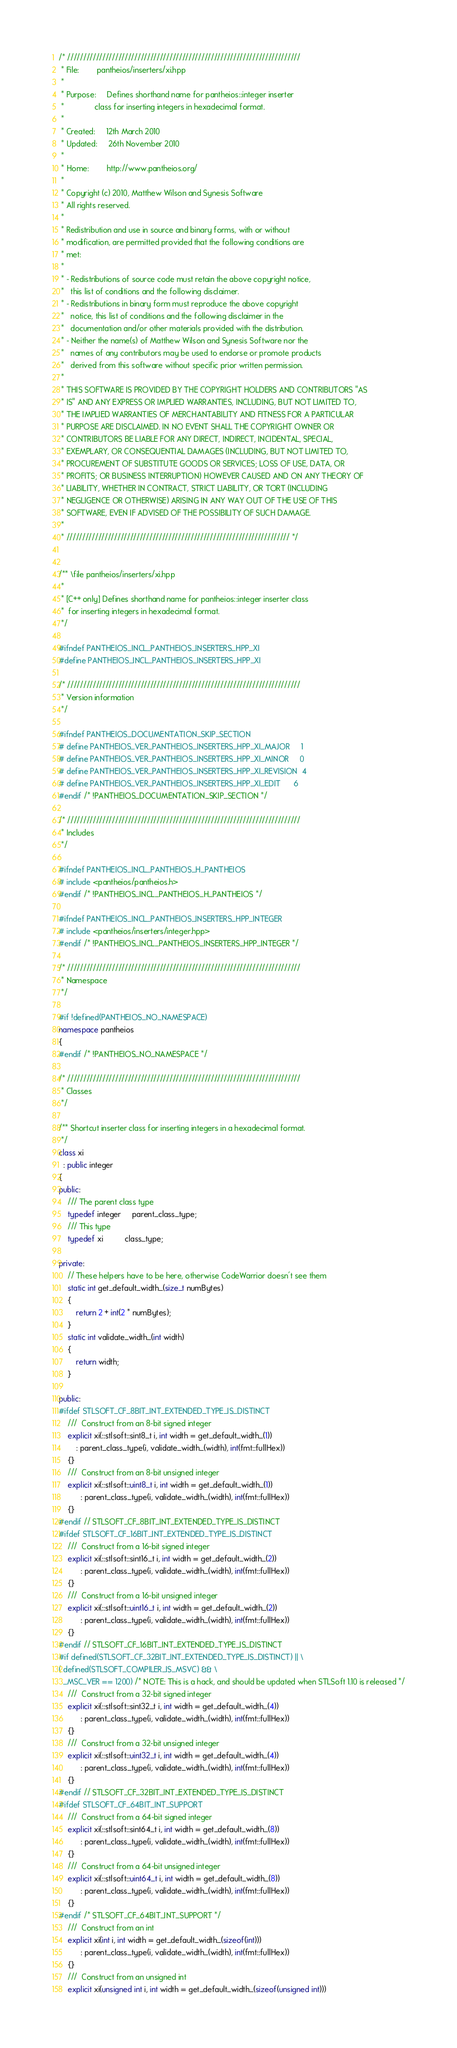<code> <loc_0><loc_0><loc_500><loc_500><_C++_>/* /////////////////////////////////////////////////////////////////////////
 * File:        pantheios/inserters/xi.hpp
 *
 * Purpose:     Defines shorthand name for pantheios::integer inserter
 *              class for inserting integers in hexadecimal format.
 *
 * Created:     12th March 2010
 * Updated:     26th November 2010
 *
 * Home:        http://www.pantheios.org/
 *
 * Copyright (c) 2010, Matthew Wilson and Synesis Software
 * All rights reserved.
 *
 * Redistribution and use in source and binary forms, with or without
 * modification, are permitted provided that the following conditions are
 * met:
 *
 * - Redistributions of source code must retain the above copyright notice,
 *   this list of conditions and the following disclaimer.
 * - Redistributions in binary form must reproduce the above copyright
 *   notice, this list of conditions and the following disclaimer in the
 *   documentation and/or other materials provided with the distribution.
 * - Neither the name(s) of Matthew Wilson and Synesis Software nor the
 *   names of any contributors may be used to endorse or promote products
 *   derived from this software without specific prior written permission.
 *
 * THIS SOFTWARE IS PROVIDED BY THE COPYRIGHT HOLDERS AND CONTRIBUTORS "AS
 * IS" AND ANY EXPRESS OR IMPLIED WARRANTIES, INCLUDING, BUT NOT LIMITED TO,
 * THE IMPLIED WARRANTIES OF MERCHANTABILITY AND FITNESS FOR A PARTICULAR
 * PURPOSE ARE DISCLAIMED. IN NO EVENT SHALL THE COPYRIGHT OWNER OR
 * CONTRIBUTORS BE LIABLE FOR ANY DIRECT, INDIRECT, INCIDENTAL, SPECIAL,
 * EXEMPLARY, OR CONSEQUENTIAL DAMAGES (INCLUDING, BUT NOT LIMITED TO,
 * PROCUREMENT OF SUBSTITUTE GOODS OR SERVICES; LOSS OF USE, DATA, OR
 * PROFITS; OR BUSINESS INTERRUPTION) HOWEVER CAUSED AND ON ANY THEORY OF
 * LIABILITY, WHETHER IN CONTRACT, STRICT LIABILITY, OR TORT (INCLUDING
 * NEGLIGENCE OR OTHERWISE) ARISING IN ANY WAY OUT OF THE USE OF THIS
 * SOFTWARE, EVEN IF ADVISED OF THE POSSIBILITY OF SUCH DAMAGE.
 *
 * ////////////////////////////////////////////////////////////////////// */


/** \file pantheios/inserters/xi.hpp
 *
 * [C++ only] Defines shorthand name for pantheios::integer inserter class
 *  for inserting integers in hexadecimal format.
 */

#ifndef PANTHEIOS_INCL_PANTHEIOS_INSERTERS_HPP_XI
#define PANTHEIOS_INCL_PANTHEIOS_INSERTERS_HPP_XI

/* /////////////////////////////////////////////////////////////////////////
 * Version information
 */

#ifndef PANTHEIOS_DOCUMENTATION_SKIP_SECTION
# define PANTHEIOS_VER_PANTHEIOS_INSERTERS_HPP_XI_MAJOR     1
# define PANTHEIOS_VER_PANTHEIOS_INSERTERS_HPP_XI_MINOR     0
# define PANTHEIOS_VER_PANTHEIOS_INSERTERS_HPP_XI_REVISION  4
# define PANTHEIOS_VER_PANTHEIOS_INSERTERS_HPP_XI_EDIT      6
#endif /* !PANTHEIOS_DOCUMENTATION_SKIP_SECTION */

/* /////////////////////////////////////////////////////////////////////////
 * Includes
 */

#ifndef PANTHEIOS_INCL_PANTHEIOS_H_PANTHEIOS
# include <pantheios/pantheios.h>
#endif /* !PANTHEIOS_INCL_PANTHEIOS_H_PANTHEIOS */

#ifndef PANTHEIOS_INCL_PANTHEIOS_INSERTERS_HPP_INTEGER
# include <pantheios/inserters/integer.hpp>
#endif /* !PANTHEIOS_INCL_PANTHEIOS_INSERTERS_HPP_INTEGER */

/* /////////////////////////////////////////////////////////////////////////
 * Namespace
 */

#if !defined(PANTHEIOS_NO_NAMESPACE)
namespace pantheios
{
#endif /* !PANTHEIOS_NO_NAMESPACE */

/* /////////////////////////////////////////////////////////////////////////
 * Classes
 */

/** Shortcut inserter class for inserting integers in a hexadecimal format.
 */
class xi
  : public integer
{
public:
    /// The parent class type
    typedef integer     parent_class_type;
    /// This type
    typedef xi          class_type;

private:
    // These helpers have to be here, otherwise CodeWarrior doesn't see them
    static int get_default_width_(size_t numBytes)
    {
        return 2 + int(2 * numBytes);
    }
    static int validate_width_(int width)
    {
        return width;
    }

public:
#ifdef STLSOFT_CF_8BIT_INT_EXTENDED_TYPE_IS_DISTINCT
    ///  Construct from an 8-bit signed integer
    explicit xi(::stlsoft::sint8_t i, int width = get_default_width_(1))
        : parent_class_type(i, validate_width_(width), int(fmt::fullHex))
    {}
    ///  Construct from an 8-bit unsigned integer
    explicit xi(::stlsoft::uint8_t i, int width = get_default_width_(1))
          : parent_class_type(i, validate_width_(width), int(fmt::fullHex))
    {}
#endif // STLSOFT_CF_8BIT_INT_EXTENDED_TYPE_IS_DISTINCT
#ifdef STLSOFT_CF_16BIT_INT_EXTENDED_TYPE_IS_DISTINCT
    ///  Construct from a 16-bit signed integer
    explicit xi(::stlsoft::sint16_t i, int width = get_default_width_(2))
          : parent_class_type(i, validate_width_(width), int(fmt::fullHex))
    {}
    ///  Construct from a 16-bit unsigned integer
    explicit xi(::stlsoft::uint16_t i, int width = get_default_width_(2))
          : parent_class_type(i, validate_width_(width), int(fmt::fullHex))
    {}
#endif // STLSOFT_CF_16BIT_INT_EXTENDED_TYPE_IS_DISTINCT
#if defined(STLSOFT_CF_32BIT_INT_EXTENDED_TYPE_IS_DISTINCT) || \
( defined(STLSOFT_COMPILER_IS_MSVC) && \
  _MSC_VER == 1200) /* NOTE: This is a hack, and should be updated when STLSoft 1.10 is released */
    ///  Construct from a 32-bit signed integer
    explicit xi(::stlsoft::sint32_t i, int width = get_default_width_(4))
          : parent_class_type(i, validate_width_(width), int(fmt::fullHex))
    {}
    ///  Construct from a 32-bit unsigned integer
    explicit xi(::stlsoft::uint32_t i, int width = get_default_width_(4))
          : parent_class_type(i, validate_width_(width), int(fmt::fullHex))
    {}
#endif // STLSOFT_CF_32BIT_INT_EXTENDED_TYPE_IS_DISTINCT
#ifdef STLSOFT_CF_64BIT_INT_SUPPORT
    ///  Construct from a 64-bit signed integer
    explicit xi(::stlsoft::sint64_t i, int width = get_default_width_(8))
          : parent_class_type(i, validate_width_(width), int(fmt::fullHex))
    {}
    ///  Construct from a 64-bit unsigned integer
    explicit xi(::stlsoft::uint64_t i, int width = get_default_width_(8))
          : parent_class_type(i, validate_width_(width), int(fmt::fullHex))
    {}
#endif /* STLSOFT_CF_64BIT_INT_SUPPORT */
    ///  Construct from an int
    explicit xi(int i, int width = get_default_width_(sizeof(int)))
          : parent_class_type(i, validate_width_(width), int(fmt::fullHex))
    {}
    ///  Construct from an unsigned int
    explicit xi(unsigned int i, int width = get_default_width_(sizeof(unsigned int)))</code> 